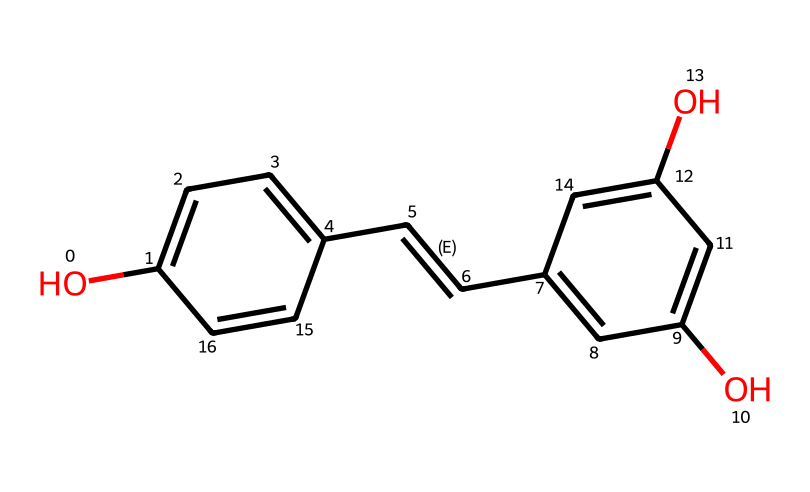What is the main functional group present in resveratrol? The SMILES representation shows that there are hydroxyl groups (-OH) attached to the aromatic rings, indicating the presence of phenolic functional groups.
Answer: hydroxyl group How many hydroxyl groups are in the structure of resveratrol? The rendered structure reveals two -OH groups directly attached to the benzene rings, confirming the presence of two hydroxyl groups in the molecule.
Answer: two What type of chemical bond connects the carbon atoms in this resveratrol structure? The SMILES representation indicates the presence of carbon-carbon (C-C) single bonds as well as a carbon-carbon double bond (C=C) between two carbon atoms. This combination shows the types of bonds present.
Answer: single and double bonds What position is the trans double bond located in the resveratrol structure? In the SMILES, the notation /C=C/ indicates that the double bond between the two carbon atoms has a trans configuration, meaning the substituents on either side of the double bond are on opposite sides.
Answer: trans How many aromatic rings are in the structure of resveratrol? The visual analysis of the chemical structure shows two distinct benzene rings, confirming their presence in the molecular architecture of resveratrol.
Answer: two Is resveratrol classified as a primary or secondary alcohol? Based on the location of the hydroxyl groups (attached to benzene rings), resveratrol is classified as a secondary alcohol since the -OH groups are on carbon atoms connected to other carbon groups.
Answer: secondary 